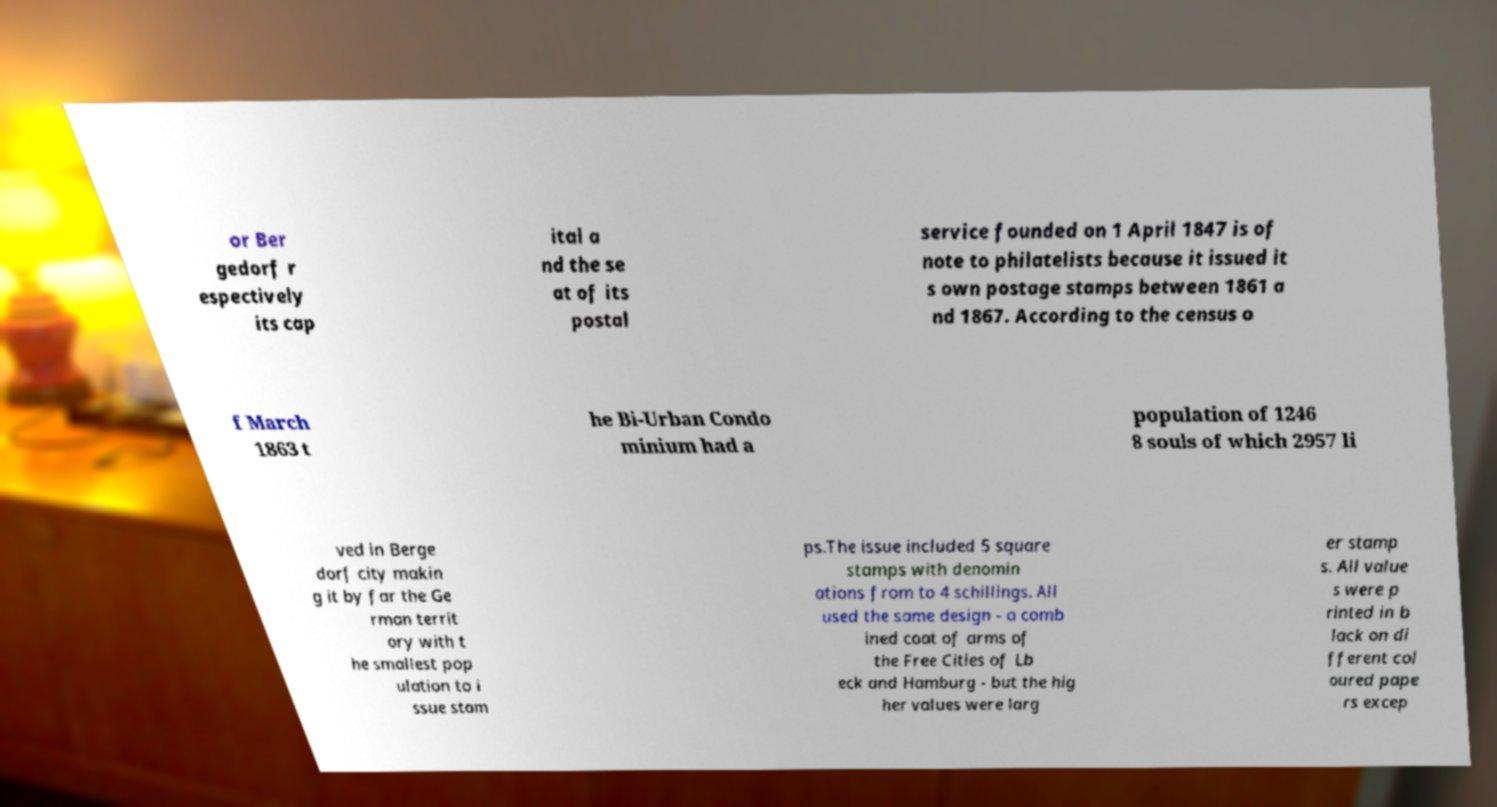Can you read and provide the text displayed in the image?This photo seems to have some interesting text. Can you extract and type it out for me? or Ber gedorf r espectively its cap ital a nd the se at of its postal service founded on 1 April 1847 is of note to philatelists because it issued it s own postage stamps between 1861 a nd 1867. According to the census o f March 1863 t he Bi-Urban Condo minium had a population of 1246 8 souls of which 2957 li ved in Berge dorf city makin g it by far the Ge rman territ ory with t he smallest pop ulation to i ssue stam ps.The issue included 5 square stamps with denomin ations from to 4 schillings. All used the same design - a comb ined coat of arms of the Free Cities of Lb eck and Hamburg - but the hig her values were larg er stamp s. All value s were p rinted in b lack on di fferent col oured pape rs excep 